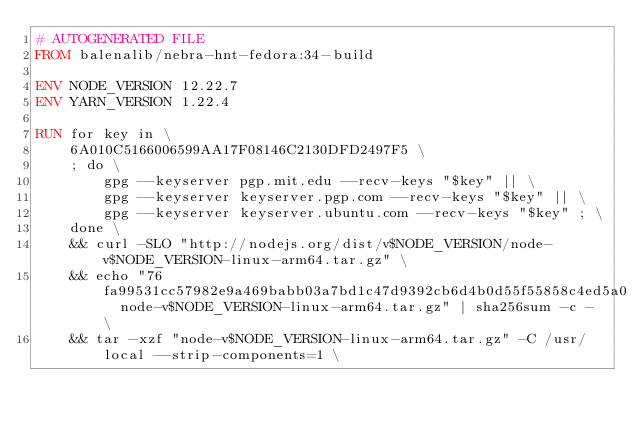Convert code to text. <code><loc_0><loc_0><loc_500><loc_500><_Dockerfile_># AUTOGENERATED FILE
FROM balenalib/nebra-hnt-fedora:34-build

ENV NODE_VERSION 12.22.7
ENV YARN_VERSION 1.22.4

RUN for key in \
	6A010C5166006599AA17F08146C2130DFD2497F5 \
	; do \
		gpg --keyserver pgp.mit.edu --recv-keys "$key" || \
		gpg --keyserver keyserver.pgp.com --recv-keys "$key" || \
		gpg --keyserver keyserver.ubuntu.com --recv-keys "$key" ; \
	done \
	&& curl -SLO "http://nodejs.org/dist/v$NODE_VERSION/node-v$NODE_VERSION-linux-arm64.tar.gz" \
	&& echo "76fa99531cc57982e9a469babb03a7bd1c47d9392cb6d4b0d55f55858c4ed5a0  node-v$NODE_VERSION-linux-arm64.tar.gz" | sha256sum -c - \
	&& tar -xzf "node-v$NODE_VERSION-linux-arm64.tar.gz" -C /usr/local --strip-components=1 \</code> 